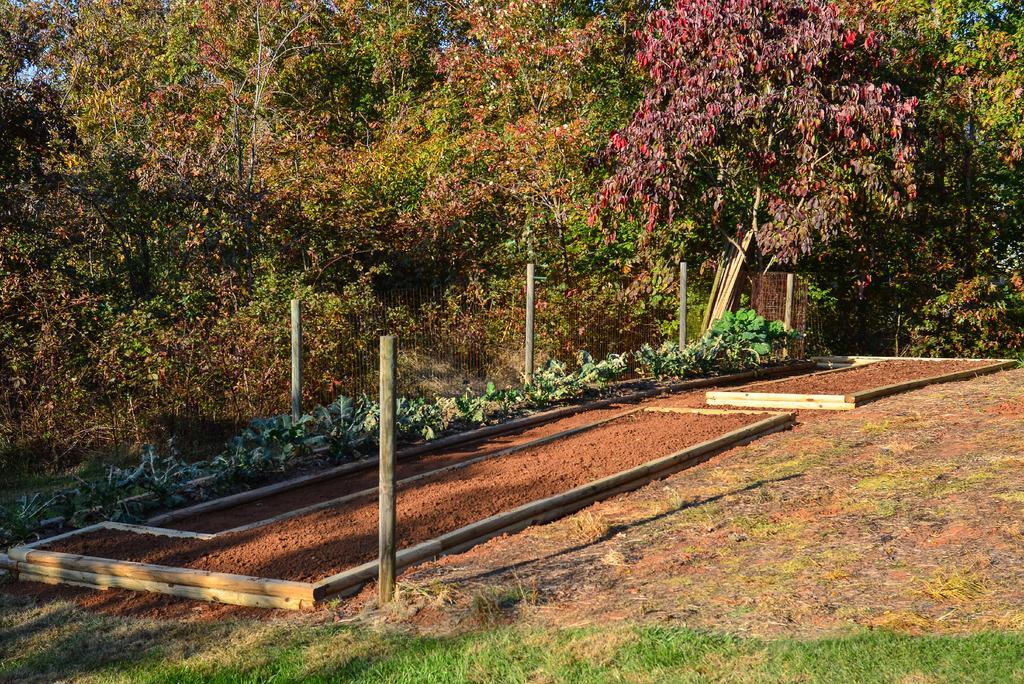Could you give a brief overview of what you see in this image? There is grass on the ground. In the background, there are wooden poles, there are words arranged on the ground, there are trees and there is sky. 